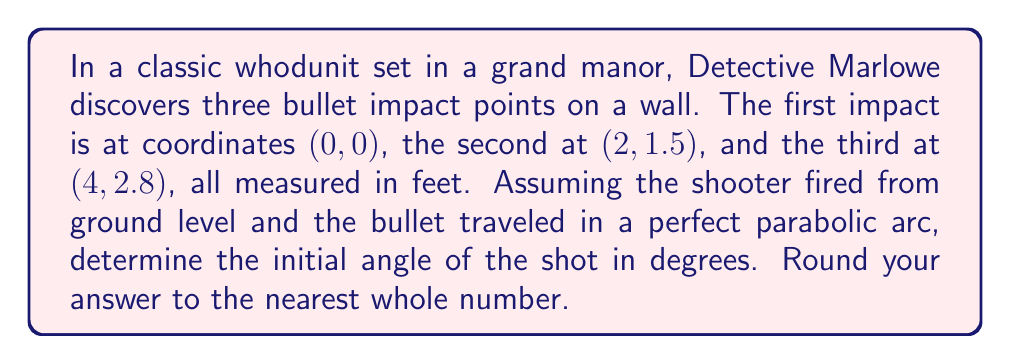Solve this math problem. Let's approach this step-by-step, old chap:

1) The trajectory of a bullet can be modeled using a parabolic equation:
   $$ y = ax^2 + bx + c $$

2) We know three points on this parabola:
   $$ (0, 0), (2, 1.5), (4, 2.8) $$

3) Substituting these points into our equation:
   $$ 0 = a(0)^2 + b(0) + c $$
   $$ 1.5 = a(2)^2 + b(2) + c $$
   $$ 2.8 = a(4)^2 + b(4) + c $$

4) From the first equation, we can deduce that $c = 0$.

5) Now we have two equations with two unknowns:
   $$ 1.5 = 4a + 2b $$
   $$ 2.8 = 16a + 4b $$

6) Solving this system of equations:
   $$ a = 0.1, b = 0.65 $$

7) Our parabola equation is now:
   $$ y = 0.1x^2 + 0.65x $$

8) The initial angle of the shot is the angle the tangent line makes with the x-axis at x = 0.

9) The derivative of our parabola gives us the slope of the tangent line:
   $$ \frac{dy}{dx} = 0.2x + 0.65 $$

10) At x = 0, the slope is 0.65.

11) The angle can be found using arctangent:
    $$ \theta = \arctan(0.65) $$

12) Converting to degrees:
    $$ \theta = \arctan(0.65) * \frac{180}{\pi} \approx 33.02^\circ $$

13) Rounding to the nearest whole number: 33°
Answer: 33° 